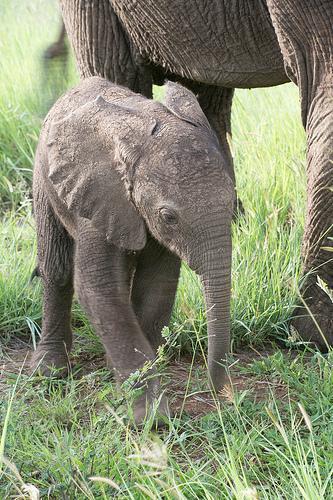How many baby elephants are there?
Give a very brief answer. 1. 